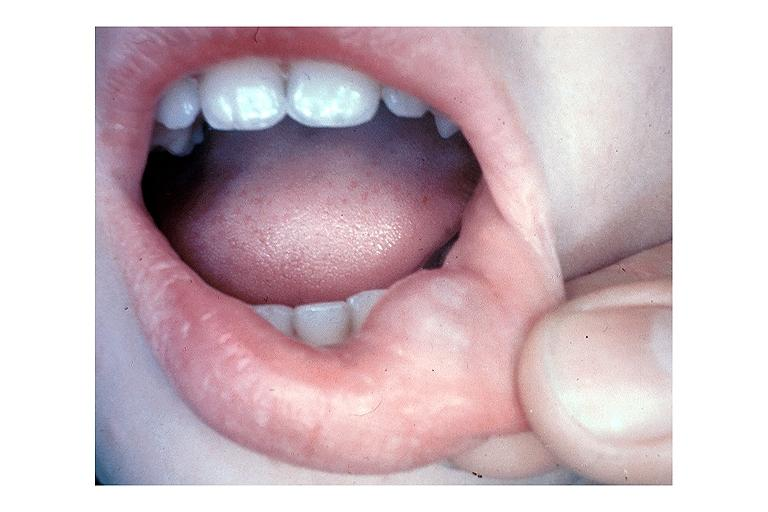what does this image show?
Answer the question using a single word or phrase. Mucocele 